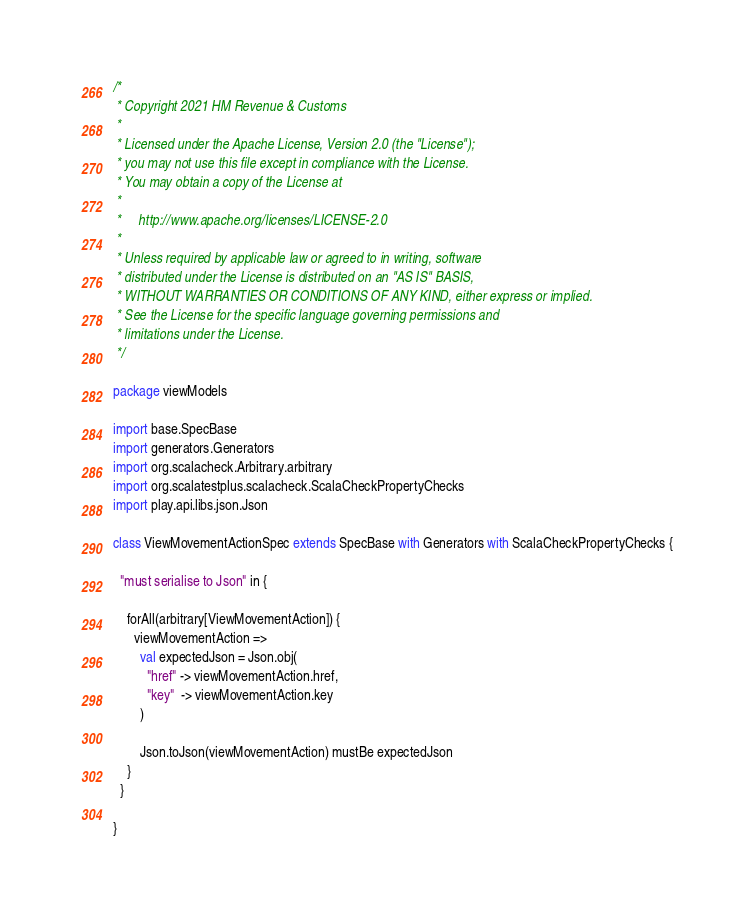Convert code to text. <code><loc_0><loc_0><loc_500><loc_500><_Scala_>/*
 * Copyright 2021 HM Revenue & Customs
 *
 * Licensed under the Apache License, Version 2.0 (the "License");
 * you may not use this file except in compliance with the License.
 * You may obtain a copy of the License at
 *
 *     http://www.apache.org/licenses/LICENSE-2.0
 *
 * Unless required by applicable law or agreed to in writing, software
 * distributed under the License is distributed on an "AS IS" BASIS,
 * WITHOUT WARRANTIES OR CONDITIONS OF ANY KIND, either express or implied.
 * See the License for the specific language governing permissions and
 * limitations under the License.
 */

package viewModels

import base.SpecBase
import generators.Generators
import org.scalacheck.Arbitrary.arbitrary
import org.scalatestplus.scalacheck.ScalaCheckPropertyChecks
import play.api.libs.json.Json

class ViewMovementActionSpec extends SpecBase with Generators with ScalaCheckPropertyChecks {

  "must serialise to Json" in {

    forAll(arbitrary[ViewMovementAction]) {
      viewMovementAction =>
        val expectedJson = Json.obj(
          "href" -> viewMovementAction.href,
          "key"  -> viewMovementAction.key
        )

        Json.toJson(viewMovementAction) mustBe expectedJson
    }
  }

}
</code> 